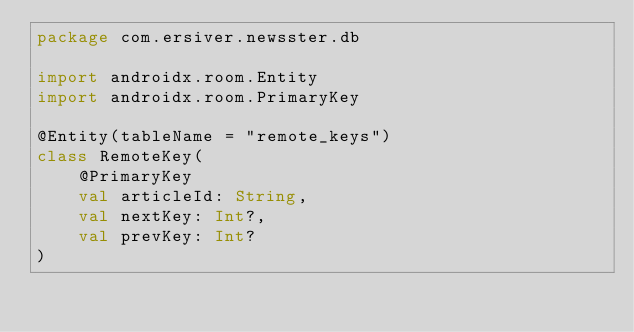<code> <loc_0><loc_0><loc_500><loc_500><_Kotlin_>package com.ersiver.newsster.db

import androidx.room.Entity
import androidx.room.PrimaryKey

@Entity(tableName = "remote_keys")
class RemoteKey(
    @PrimaryKey
    val articleId: String,
    val nextKey: Int?,
    val prevKey: Int?
)</code> 